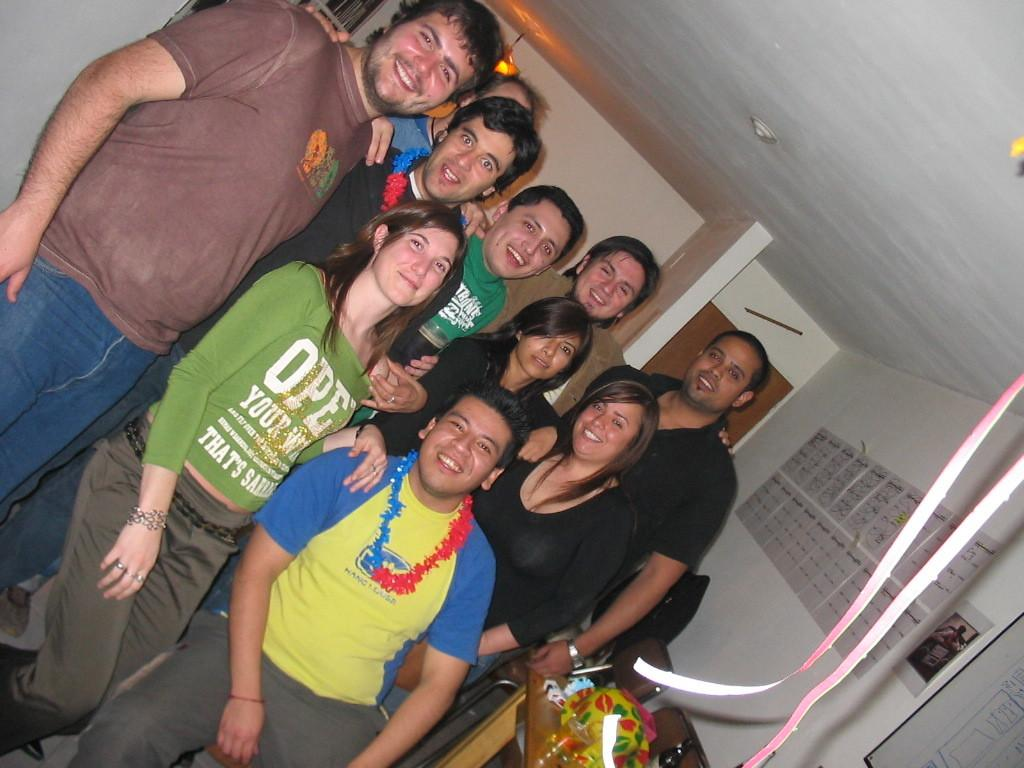What is happening in the middle of the image? There is a group of people in the middle of the image. How are the people in the image positioned? The people are standing and smiling. What can be seen at the back side of the image? There is a light at the back side of the image. What is attached to the wall on the right side of the image? There are papers stuck to the wall on the right side of the image. Can you see a cannon being fired in the image? No, there is no cannon or any indication of a cannon being fired in the image. Is there an airplane flying in the background of the image? No, there is no airplane or any reference to an airplane in the image. 